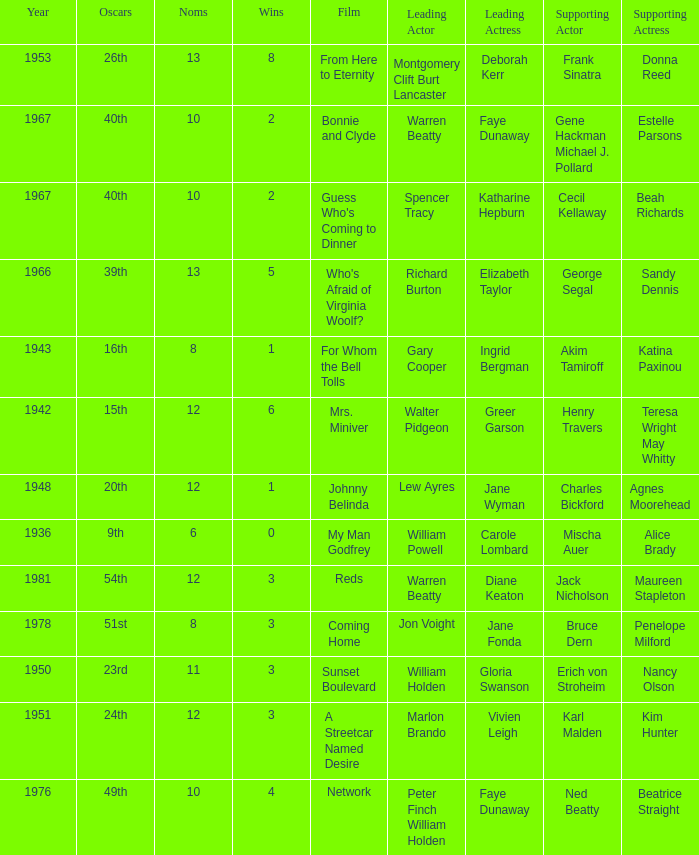Which film had Charles Bickford as supporting actor? Johnny Belinda. 